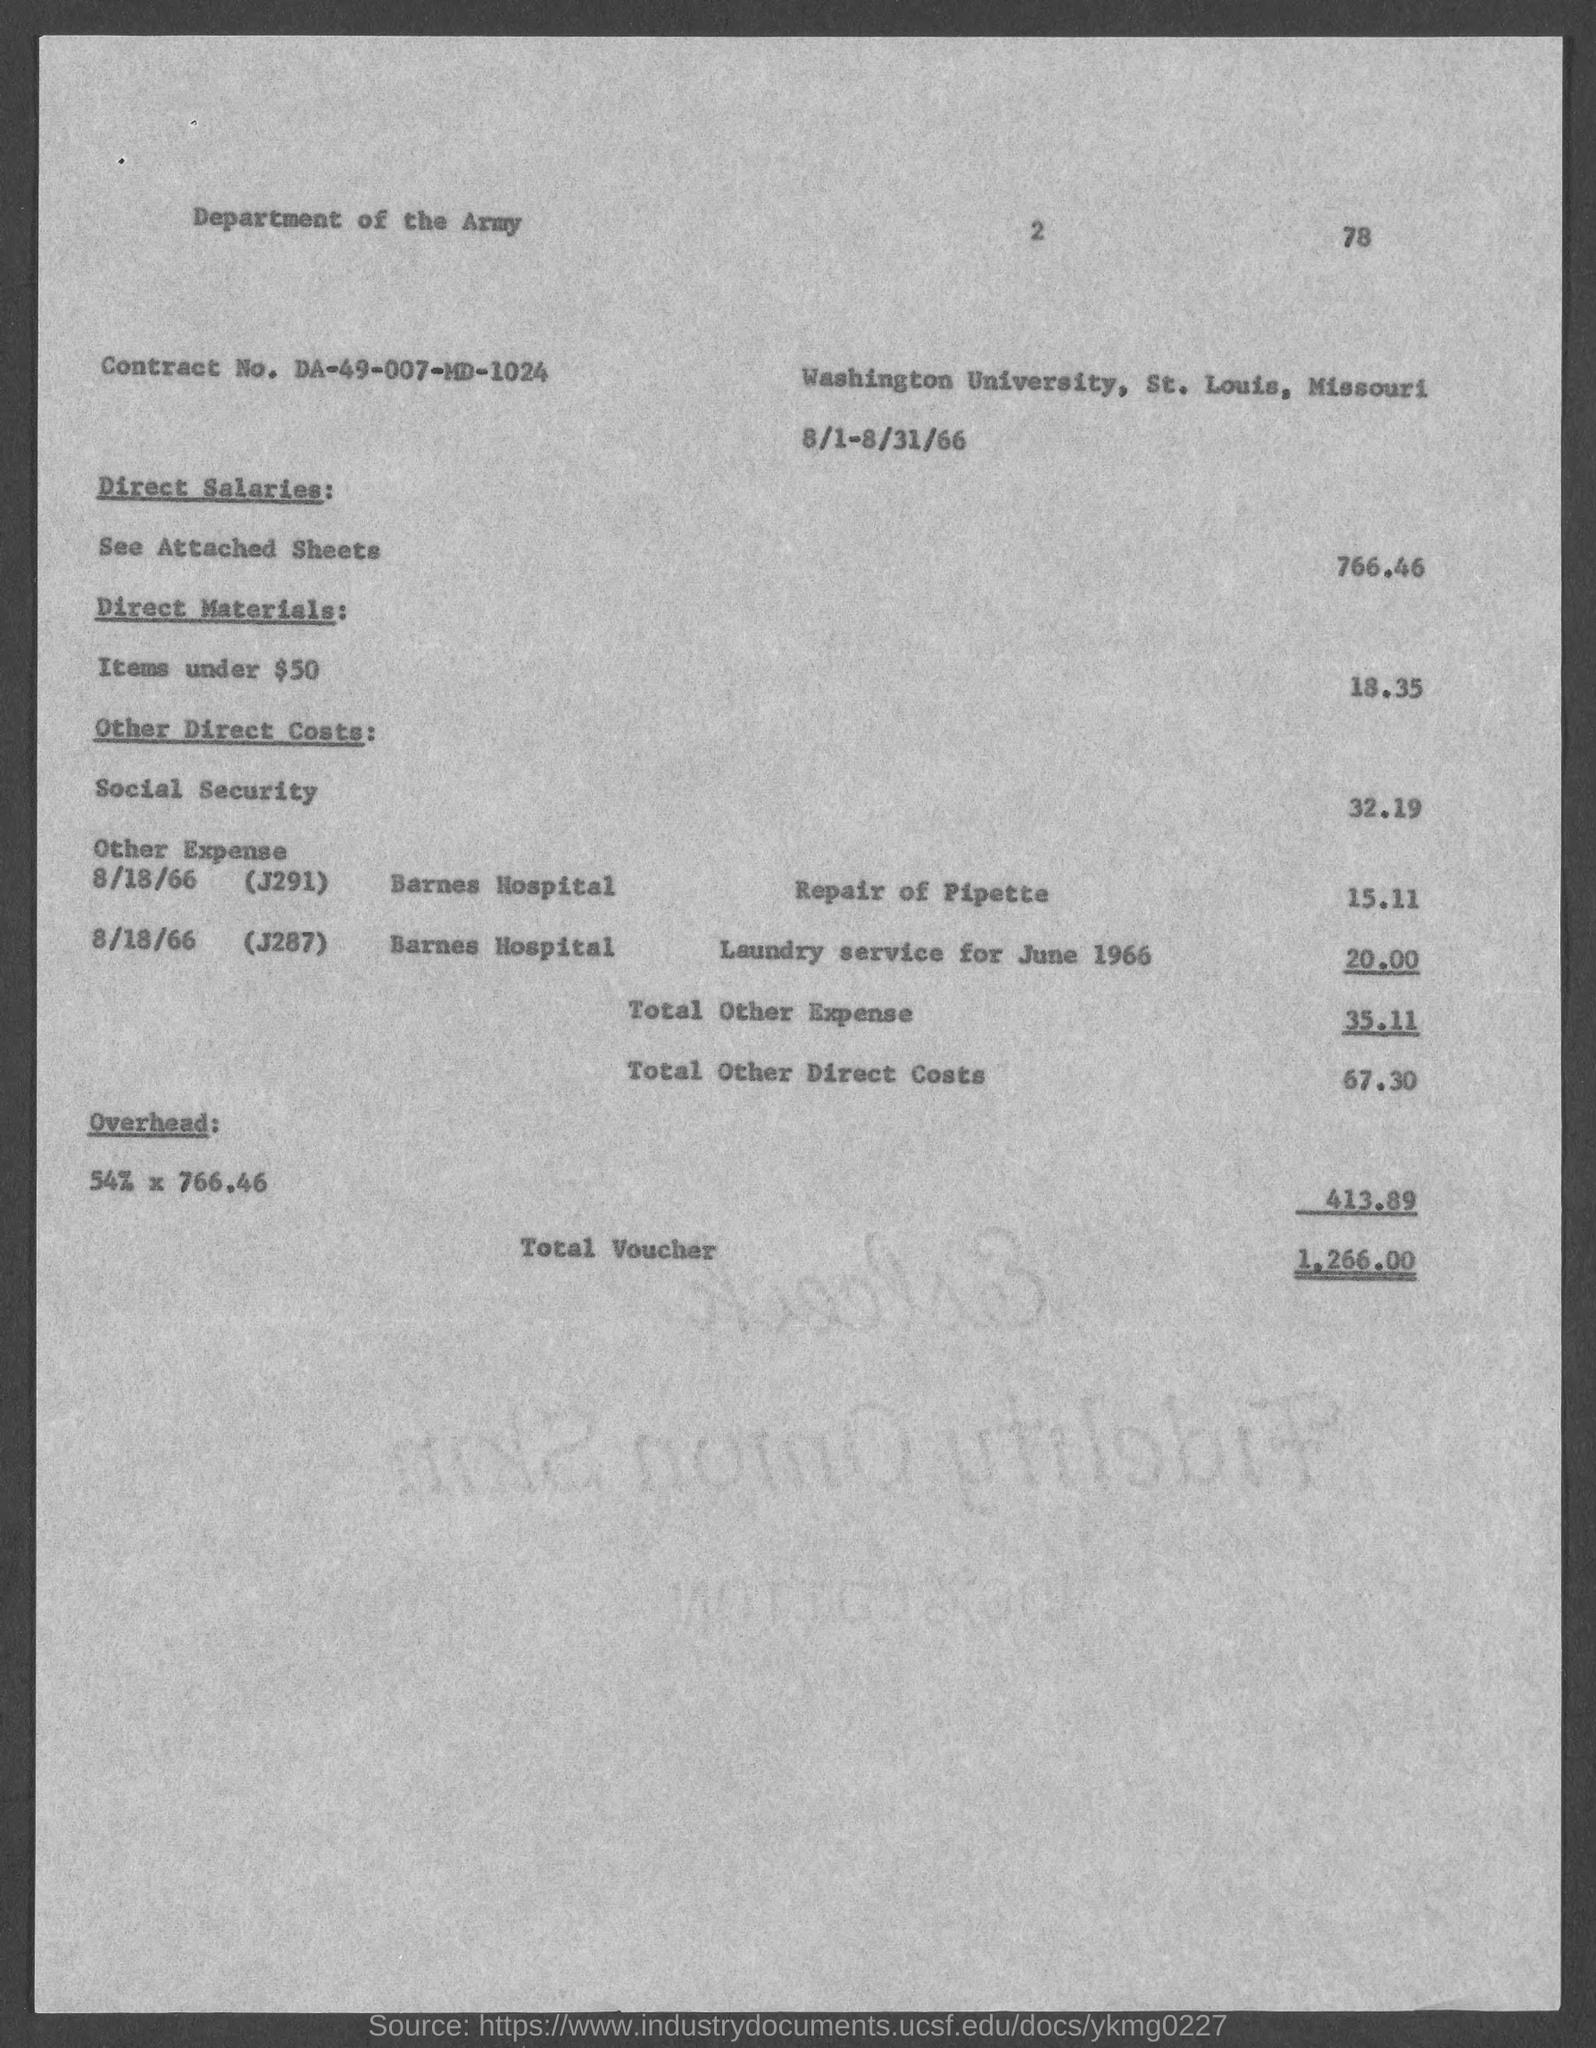What is Contract No.?
Make the answer very short. DA-49-007-MD-1024. What are the total voucher?
Your answer should be compact. 1,266.00. 